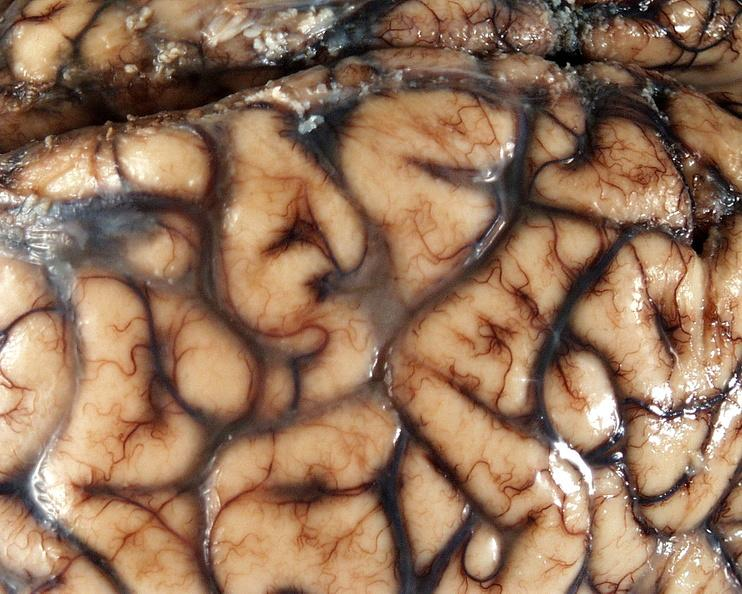s nervous present?
Answer the question using a single word or phrase. Yes 